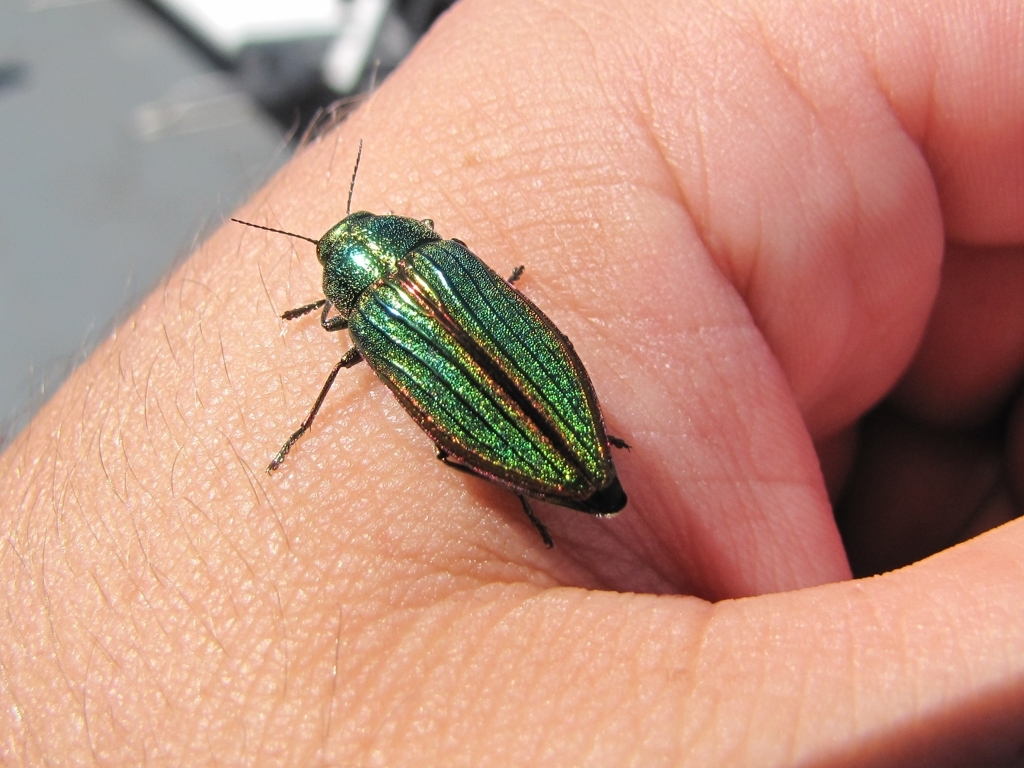Given its size and the visible details, might this insect be commonly found in this person's environment? Yes, the insect could be common in the person's environment, especially if the location supports the appropriate habitat, like meadows or woodland edges. Observing an insect like this at such close proximity suggests it may not be uncommon or the person is in an area where these insects thrive. 